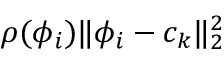Convert formula to latex. <formula><loc_0><loc_0><loc_500><loc_500>\rho ( \phi _ { i } ) \| \phi _ { i } - c _ { k } \| _ { 2 } ^ { 2 }</formula> 